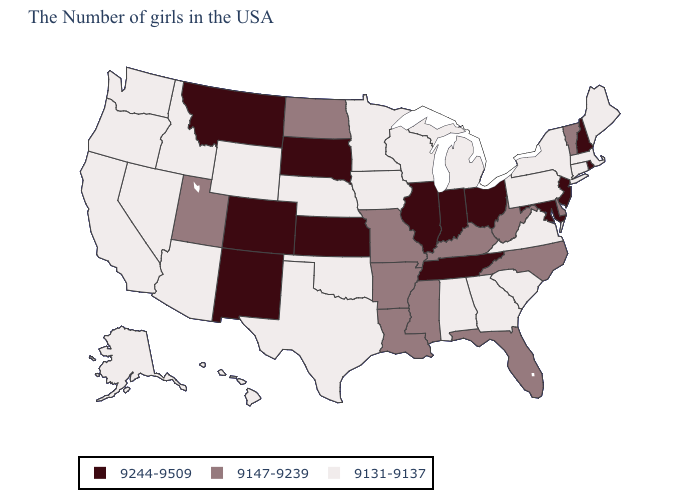Which states have the lowest value in the Northeast?
Answer briefly. Maine, Massachusetts, Connecticut, New York, Pennsylvania. What is the value of Nevada?
Be succinct. 9131-9137. Which states have the lowest value in the USA?
Concise answer only. Maine, Massachusetts, Connecticut, New York, Pennsylvania, Virginia, South Carolina, Georgia, Michigan, Alabama, Wisconsin, Minnesota, Iowa, Nebraska, Oklahoma, Texas, Wyoming, Arizona, Idaho, Nevada, California, Washington, Oregon, Alaska, Hawaii. How many symbols are there in the legend?
Answer briefly. 3. What is the highest value in states that border New Mexico?
Write a very short answer. 9244-9509. What is the lowest value in states that border Tennessee?
Be succinct. 9131-9137. Does the map have missing data?
Write a very short answer. No. Which states have the lowest value in the Northeast?
Write a very short answer. Maine, Massachusetts, Connecticut, New York, Pennsylvania. Name the states that have a value in the range 9131-9137?
Answer briefly. Maine, Massachusetts, Connecticut, New York, Pennsylvania, Virginia, South Carolina, Georgia, Michigan, Alabama, Wisconsin, Minnesota, Iowa, Nebraska, Oklahoma, Texas, Wyoming, Arizona, Idaho, Nevada, California, Washington, Oregon, Alaska, Hawaii. What is the highest value in states that border Nevada?
Be succinct. 9147-9239. Does Vermont have the lowest value in the Northeast?
Be succinct. No. Does North Carolina have a lower value than Pennsylvania?
Quick response, please. No. Among the states that border Maryland , does West Virginia have the highest value?
Keep it brief. Yes. What is the value of Pennsylvania?
Short answer required. 9131-9137. 